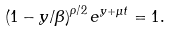<formula> <loc_0><loc_0><loc_500><loc_500>\left ( 1 - { y } / { \beta } \right ) ^ { \rho / 2 } e ^ { y + \mu t } = 1 .</formula> 